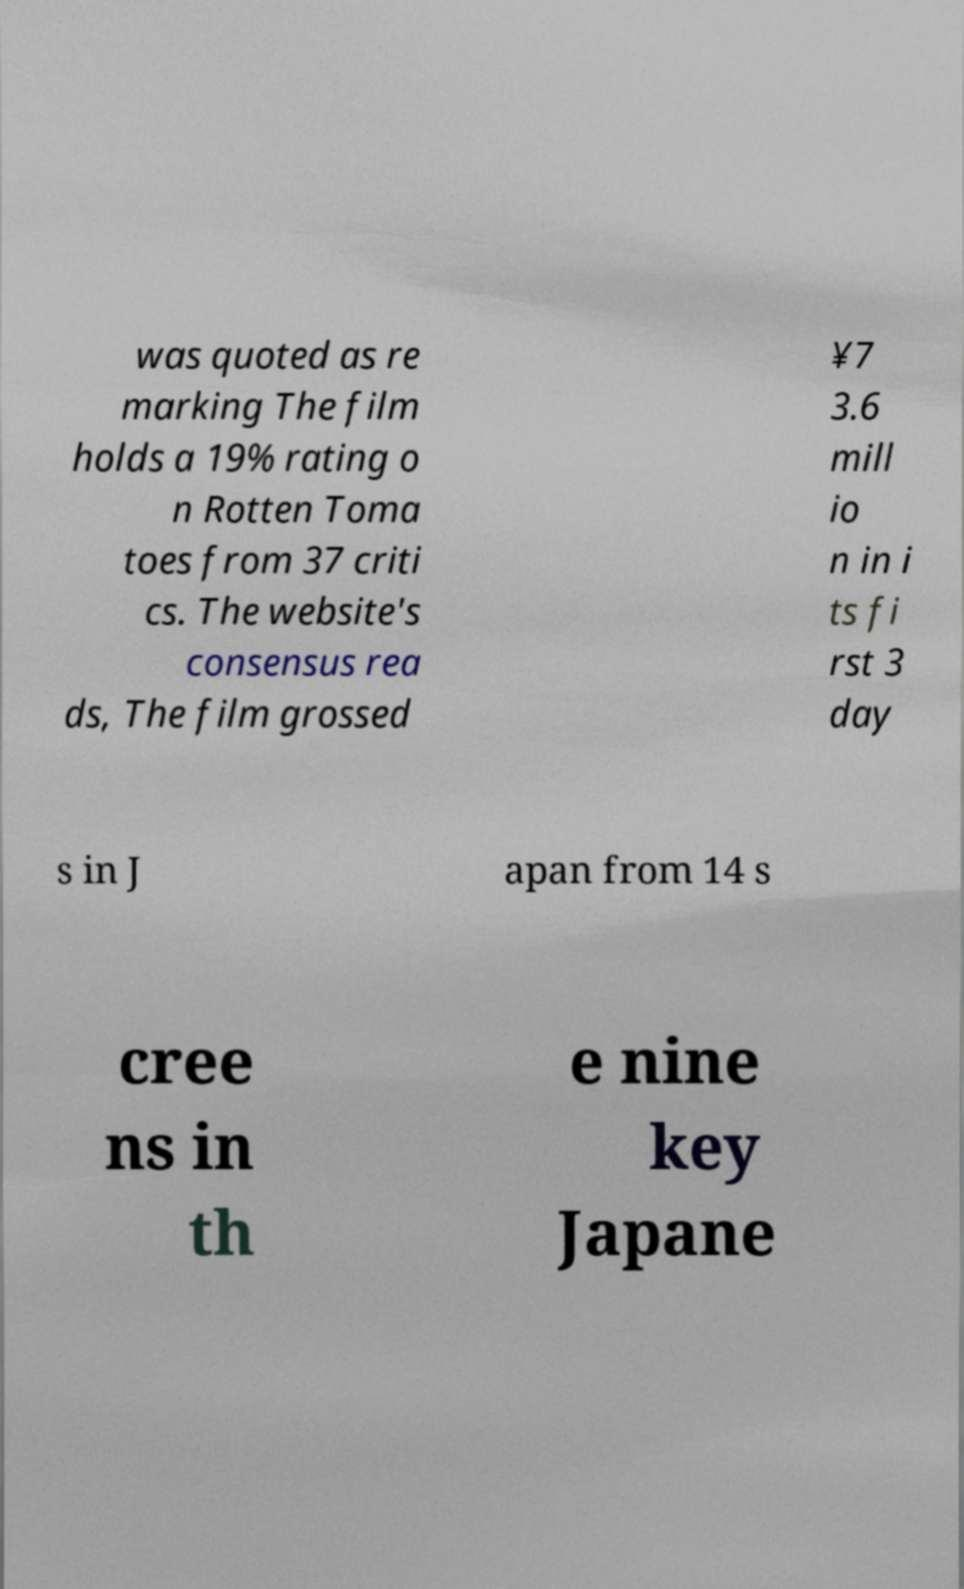Can you read and provide the text displayed in the image?This photo seems to have some interesting text. Can you extract and type it out for me? was quoted as re marking The film holds a 19% rating o n Rotten Toma toes from 37 criti cs. The website's consensus rea ds, The film grossed ¥7 3.6 mill io n in i ts fi rst 3 day s in J apan from 14 s cree ns in th e nine key Japane 